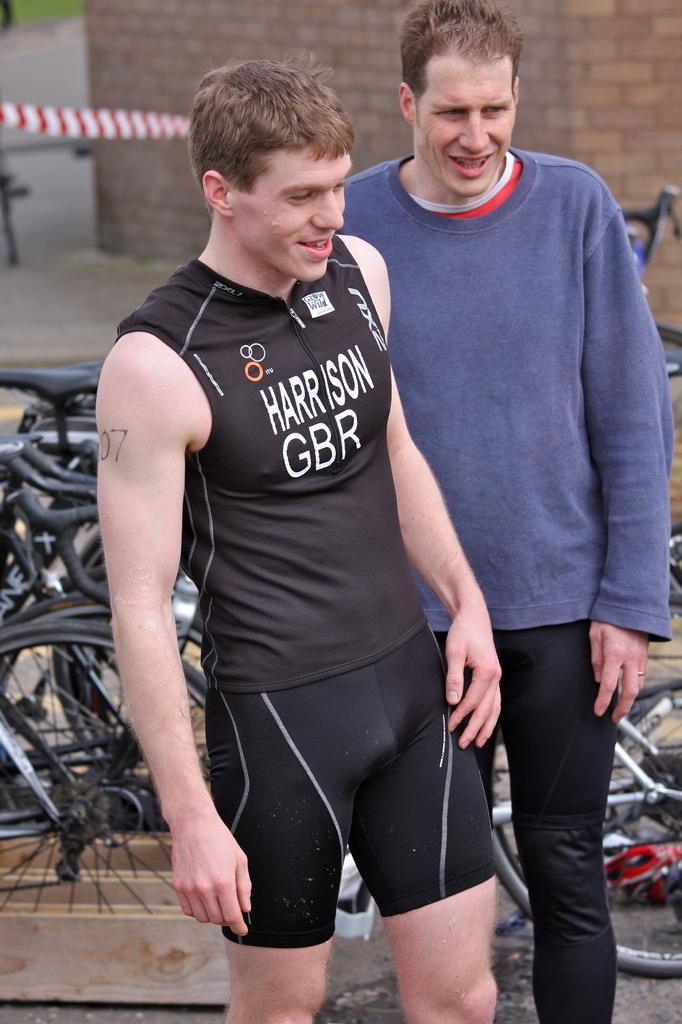<image>
Create a compact narrative representing the image presented. A man wearing a black bicycle outfit with Harrison written in front is standing in front of many bicycles. 